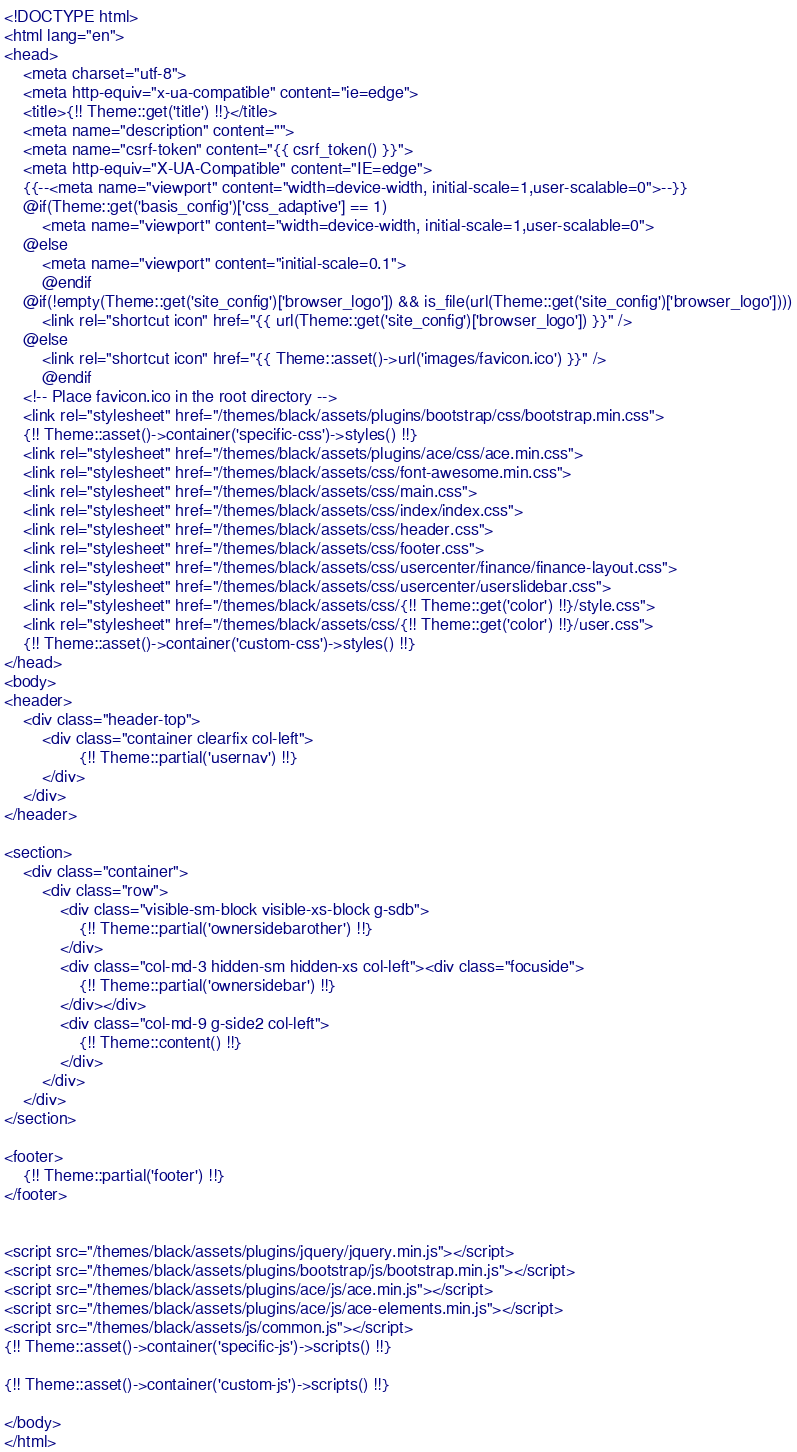Convert code to text. <code><loc_0><loc_0><loc_500><loc_500><_PHP_><!DOCTYPE html>
<html lang="en">
<head>
    <meta charset="utf-8">
    <meta http-equiv="x-ua-compatible" content="ie=edge">
    <title>{!! Theme::get('title') !!}</title>
    <meta name="description" content="">
    <meta name="csrf-token" content="{{ csrf_token() }}">
    <meta http-equiv="X-UA-Compatible" content="IE=edge">
    {{--<meta name="viewport" content="width=device-width, initial-scale=1,user-scalable=0">--}}
    @if(Theme::get('basis_config')['css_adaptive'] == 1)
        <meta name="viewport" content="width=device-width, initial-scale=1,user-scalable=0">
    @else
        <meta name="viewport" content="initial-scale=0.1">
        @endif
    @if(!empty(Theme::get('site_config')['browser_logo']) && is_file(url(Theme::get('site_config')['browser_logo'])))
        <link rel="shortcut icon" href="{{ url(Theme::get('site_config')['browser_logo']) }}" />
    @else
        <link rel="shortcut icon" href="{{ Theme::asset()->url('images/favicon.ico') }}" />
        @endif
    <!-- Place favicon.ico in the root directory -->
    <link rel="stylesheet" href="/themes/black/assets/plugins/bootstrap/css/bootstrap.min.css">
    {!! Theme::asset()->container('specific-css')->styles() !!}
    <link rel="stylesheet" href="/themes/black/assets/plugins/ace/css/ace.min.css">
    <link rel="stylesheet" href="/themes/black/assets/css/font-awesome.min.css">
    <link rel="stylesheet" href="/themes/black/assets/css/main.css">
    <link rel="stylesheet" href="/themes/black/assets/css/index/index.css">
    <link rel="stylesheet" href="/themes/black/assets/css/header.css">
    <link rel="stylesheet" href="/themes/black/assets/css/footer.css">
    <link rel="stylesheet" href="/themes/black/assets/css/usercenter/finance/finance-layout.css">
    <link rel="stylesheet" href="/themes/black/assets/css/usercenter/userslidebar.css">
    <link rel="stylesheet" href="/themes/black/assets/css/{!! Theme::get('color') !!}/style.css">
    <link rel="stylesheet" href="/themes/black/assets/css/{!! Theme::get('color') !!}/user.css">
    {!! Theme::asset()->container('custom-css')->styles() !!}
</head>
<body>
<header>
    <div class="header-top">
        <div class="container clearfix col-left">
                {!! Theme::partial('usernav') !!}
        </div>
    </div>
</header>

<section>
    <div class="container">
        <div class="row">
            <div class="visible-sm-block visible-xs-block g-sdb">
                {!! Theme::partial('ownersidebarother') !!}
            </div>
            <div class="col-md-3 hidden-sm hidden-xs col-left"><div class="focuside">
                {!! Theme::partial('ownersidebar') !!}
            </div></div>
            <div class="col-md-9 g-side2 col-left">
                {!! Theme::content() !!}
            </div>
        </div>
    </div>
</section>

<footer>
    {!! Theme::partial('footer') !!}
</footer>


<script src="/themes/black/assets/plugins/jquery/jquery.min.js"></script>
<script src="/themes/black/assets/plugins/bootstrap/js/bootstrap.min.js"></script>
<script src="/themes/black/assets/plugins/ace/js/ace.min.js"></script>
<script src="/themes/black/assets/plugins/ace/js/ace-elements.min.js"></script>
<script src="/themes/black/assets/js/common.js"></script>
{!! Theme::asset()->container('specific-js')->scripts() !!}

{!! Theme::asset()->container('custom-js')->scripts() !!}

</body>
</html>

</code> 